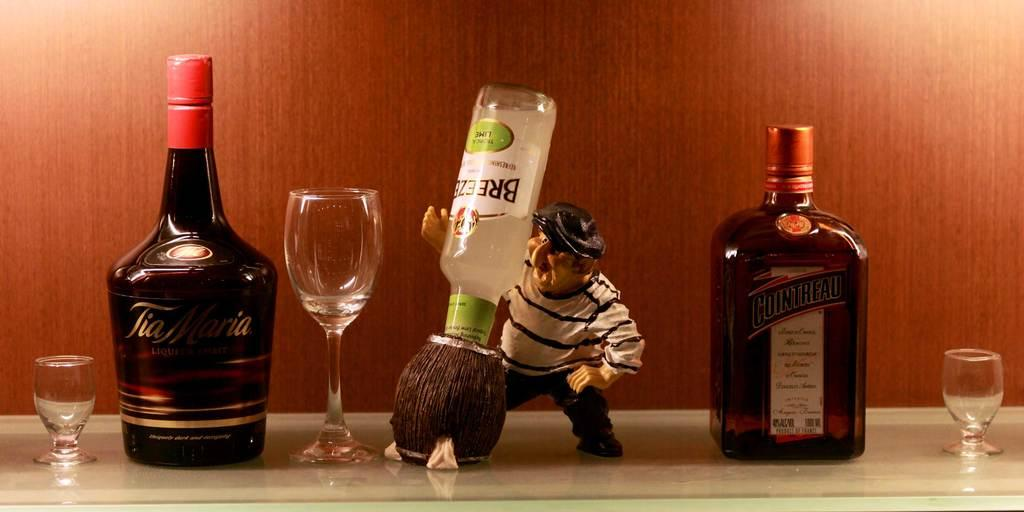What type of container is present in the image? There is a bottle in the image. What type of glassware is present in the image? There is a wine glass in the image. Can you describe the person in the image? The person in the image is wearing a cap. What object in the image is not a container or glassware? The image depicts a toy. What country is the person in the image visiting? The provided facts do not mention any information about the person visiting a country, so we cannot determine this from the image. What does the toy smell like in the image? The provided facts do not mention any information about the toy having a smell, so we cannot determine this from the image. 